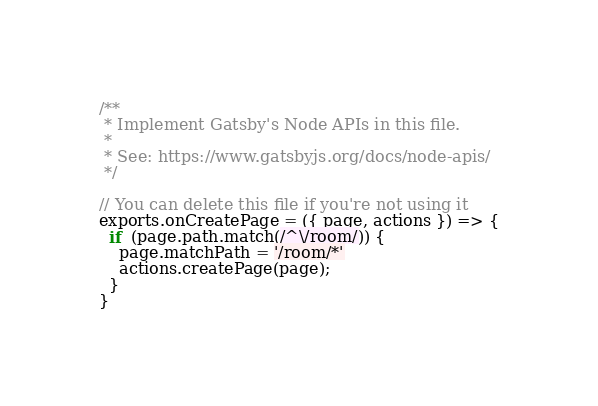<code> <loc_0><loc_0><loc_500><loc_500><_JavaScript_>/**
 * Implement Gatsby's Node APIs in this file.
 *
 * See: https://www.gatsbyjs.org/docs/node-apis/
 */

// You can delete this file if you're not using it
exports.onCreatePage = ({ page, actions }) => {
  if  (page.path.match(/^\/room/)) {
    page.matchPath = '/room/*'
    actions.createPage(page);
  }
}</code> 